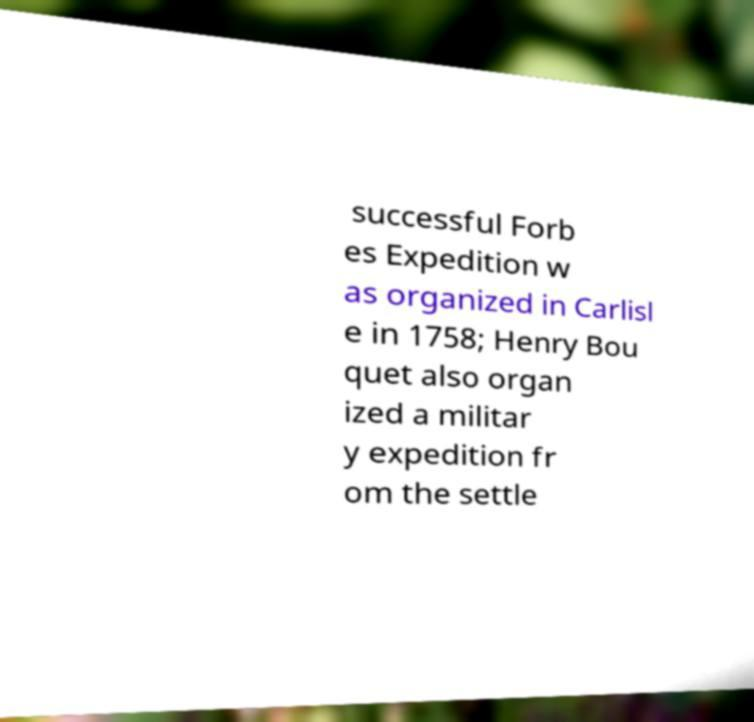Could you assist in decoding the text presented in this image and type it out clearly? successful Forb es Expedition w as organized in Carlisl e in 1758; Henry Bou quet also organ ized a militar y expedition fr om the settle 